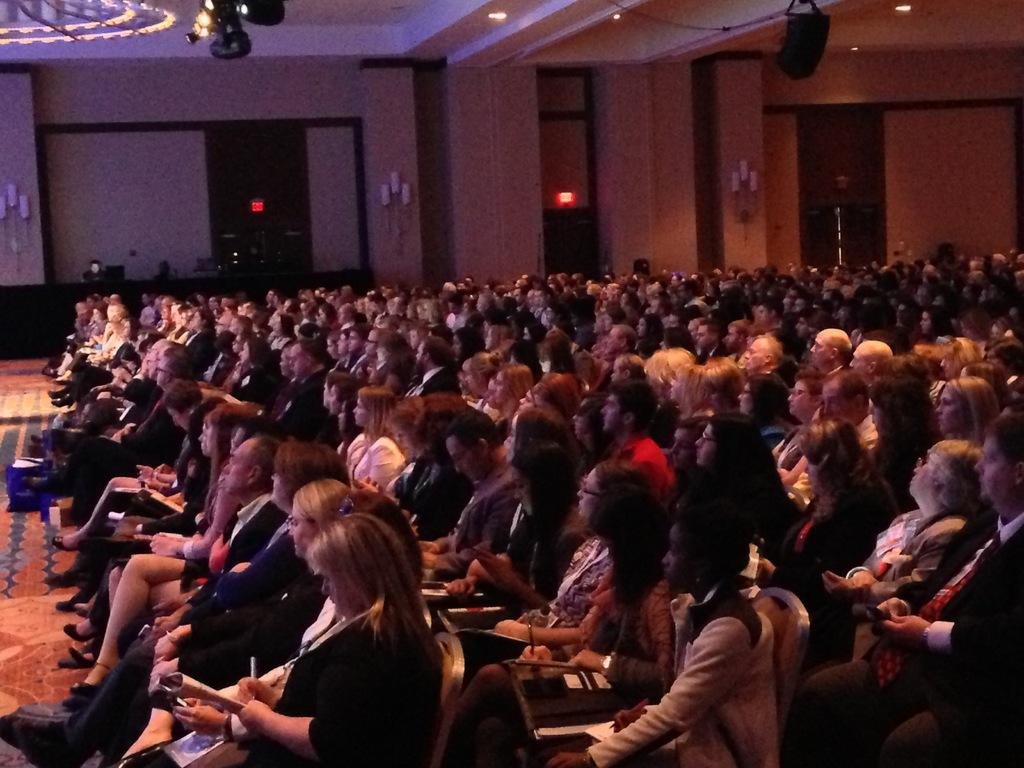What type of location is depicted in the image? The image shows an inside view of an auditorium. What can be observed about the people in the auditorium? There are groups of people in the auditorium, and they are wearing clothes. How are the people positioned in the auditorium? The people are sitting on chairs beside the wall. What can be seen at the top of the image? There are lights at the top of the image. What is the topic of the heated bit-related discussion happening in the auditorium? There is no discussion or mention of a "bit" in the image; it simply shows an auditorium with people sitting on chairs beside the wall. 